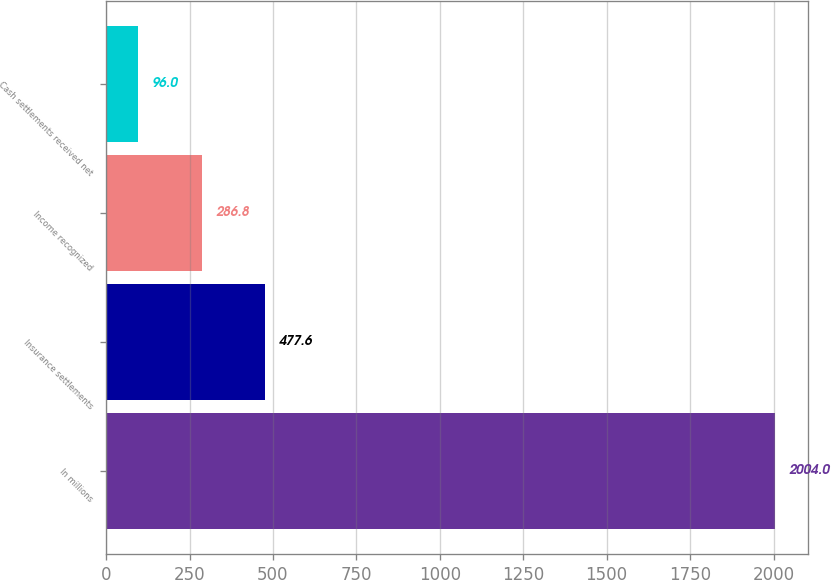Convert chart. <chart><loc_0><loc_0><loc_500><loc_500><bar_chart><fcel>In millions<fcel>Insurance settlements<fcel>Income recognized<fcel>Cash settlements received net<nl><fcel>2004<fcel>477.6<fcel>286.8<fcel>96<nl></chart> 